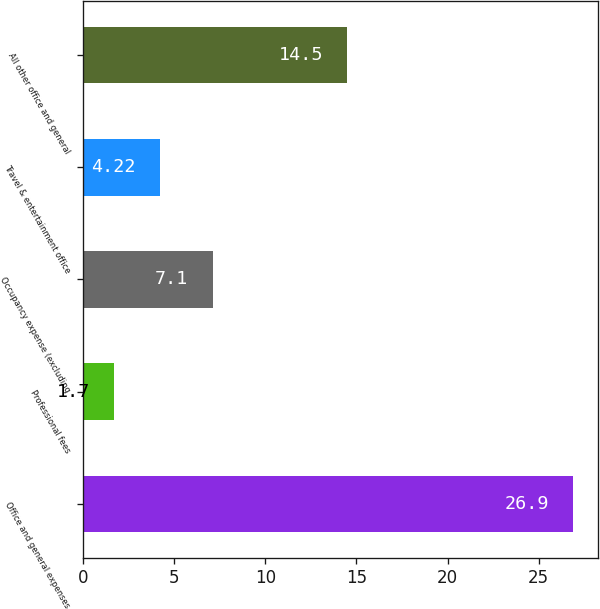Convert chart to OTSL. <chart><loc_0><loc_0><loc_500><loc_500><bar_chart><fcel>Office and general expenses<fcel>Professional fees<fcel>Occupancy expense (excluding<fcel>Travel & entertainment office<fcel>All other office and general<nl><fcel>26.9<fcel>1.7<fcel>7.1<fcel>4.22<fcel>14.5<nl></chart> 